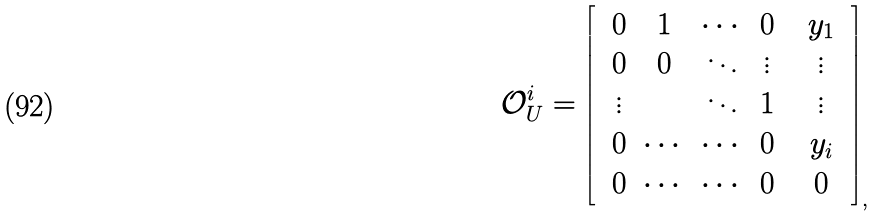<formula> <loc_0><loc_0><loc_500><loc_500>\mathcal { O } _ { U } ^ { i } = \left [ \begin{array} { c c } \begin{array} { c c c c } 0 & 1 & \cdots & 0 \\ 0 & 0 & \ddots & \vdots \\ \vdots & \, & \ddots & 1 \\ 0 & \cdots & \cdots & 0 \\ \end{array} & \begin{array} { c } y _ { 1 } \\ \vdots \\ \vdots \\ y _ { i } \end{array} \\ \begin{array} { c c c c } 0 & \cdots & \cdots & 0 \end{array} & 0 \end{array} \right ] _ { , }</formula> 